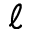<formula> <loc_0><loc_0><loc_500><loc_500>\ell</formula> 